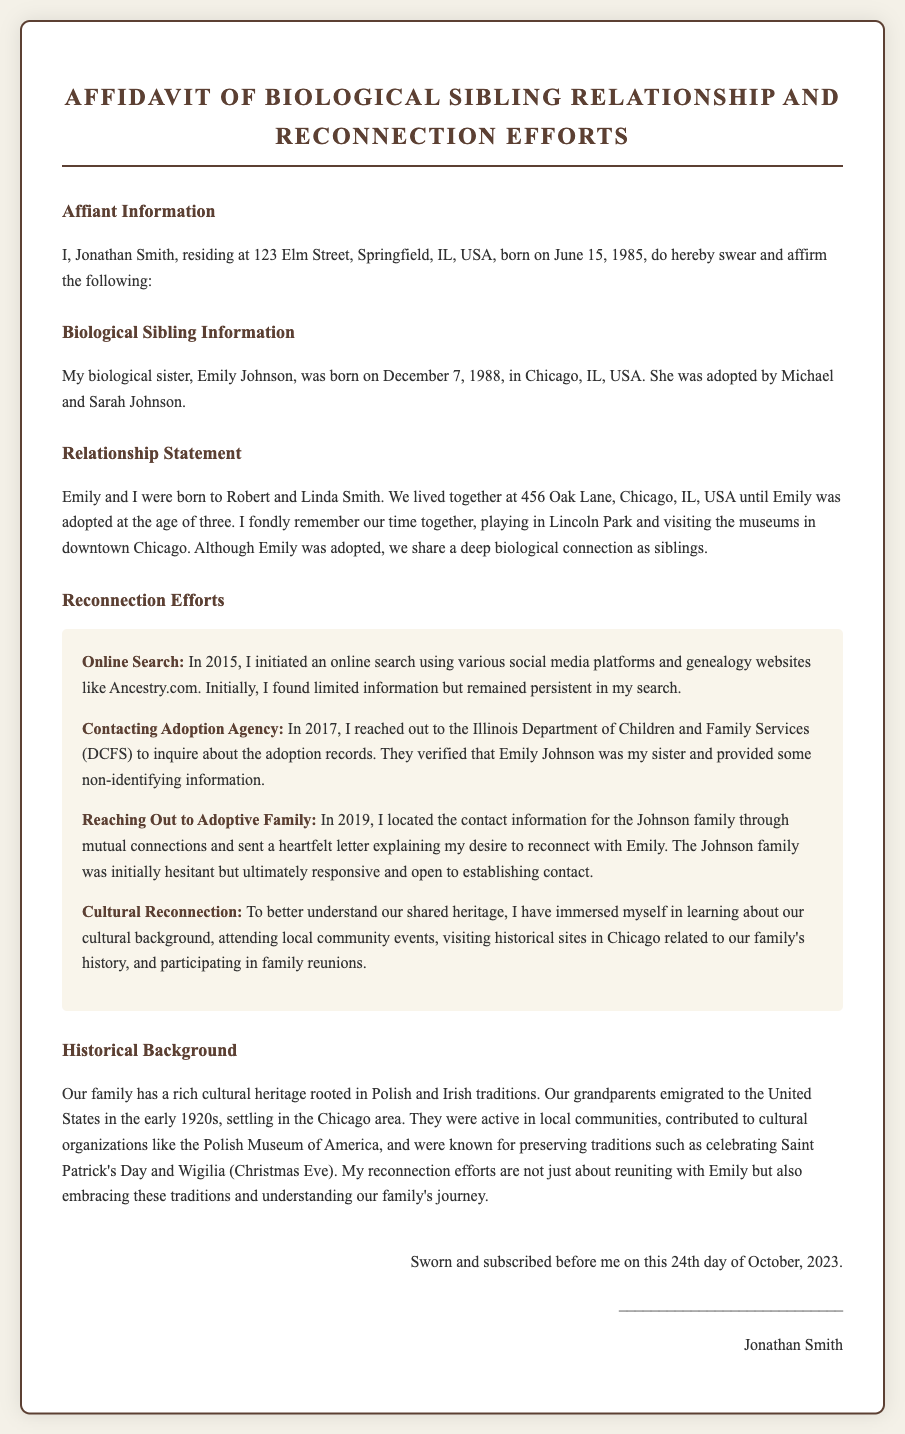what is the name of the affiant? The affiant is the individual who swears to the information in the affidavit, and in this document, it is Jonathan Smith.
Answer: Jonathan Smith what is the name of the biological sister? The biological sister mentioned in the affidavit is directly identified as Emily Johnson.
Answer: Emily Johnson when was Emily Johnson born? Emily Johnson's date of birth is explicitly stated in the document, which is December 7, 1988.
Answer: December 7, 1988 what organization did the affiant contact in 2017? The organization contacted by the affiant in 2017 for information was the Illinois Department of Children and Family Services (DCFS).
Answer: Illinois Department of Children and Family Services what cultural events did the affiant participate in for reconnection? The affiant participated in local community events, which signifies efforts to reconnect with their heritage.
Answer: local community events what year did the affiant begin their online search? The document states that the online search was initiated in 2015.
Answer: 2015 how old was Emily when she was adopted? The document explains that Emily was adopted at the age of three.
Answer: three what heritage does the family have? The affidavit mentions that the family's cultural heritage is rooted in Polish and Irish traditions.
Answer: Polish and Irish what was one of the activities mentioned for embracing family traditions? One of the activities for embracing traditions included celebrating Wigilia (Christmas Eve).
Answer: celebrating Wigilia 